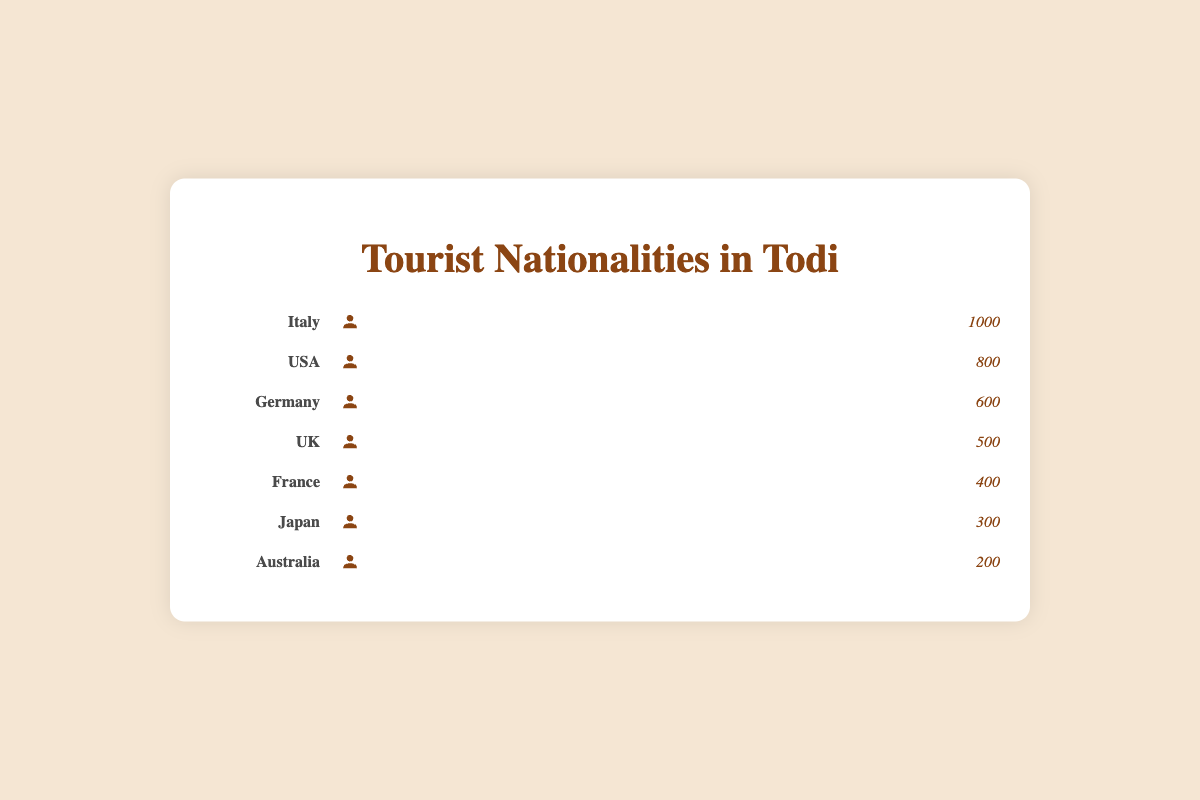What's the total number of visitors from all nationalities? To find the total number of visitors, add up the visitors from all nationalities: 1000 (Italy) + 800 (USA) + 600 (Germany) + 500 (UK) + 400 (France) + 300 (Japan) + 200 (Australia). This gives a total of 3800 visitors.
Answer: 3800 Which nationality has the highest number of visitors? By looking at the visual representation, we can see that Italy has the most icons, indicating the highest number of visitors at 1000.
Answer: Italy How many more visitors are there from USA than from France? To find the difference in visitors between the USA and France, subtract the number of visitors from France from the number of visitors from the USA: 800 (USA) - 400 (France) = 400.
Answer: 400 What's the average number of visitors from all countries? To calculate the average number of visitors, sum the total number of visitors (3800) and divide by the number of nationalities (7): 3800 / 7 ≈ 543.
Answer: 543 Which two nationalities have a combined total of 1100 visitors? By examining the visitor numbers, we find that Germany (600) and UK (500) together have a combined total of 1100 visitors (600 + 500 = 1100).
Answer: Germany and UK How many icons represent the visitors from Japan? Each icon seems to represent 100 visitors, and Japan has 300 visitors. Therefore, 300 visitors / 100 visitors per icon = 3 icons.
Answer: 3 icons What's the difference in visitor numbers between the nationality with the most visitors and the one with the fewest visitors? To find the difference, subtract the number of visitors from Australia (200) from the number of visitors from Italy (1000): 1000 - 200 = 800.
Answer: 800 Which nationality has the second lowest number of visitors? By analyzing the numbers, Australia has the lowest number at 200, and Japan has the second lowest at 300.
Answer: Japan What is the ratio of visitors from Italy to visitors from Australia? The ratio of visitors from Italy (1000) to Australia (200) is calculated by dividing 1000 by 200, which gives a ratio of 5:1.
Answer: 5:1 How many nationalities have more than 500 visitors? By looking at the data, Italy (1000), USA (800), and Germany (600) all have more than 500 visitors, making it a total of 3 nationalities.
Answer: 3 